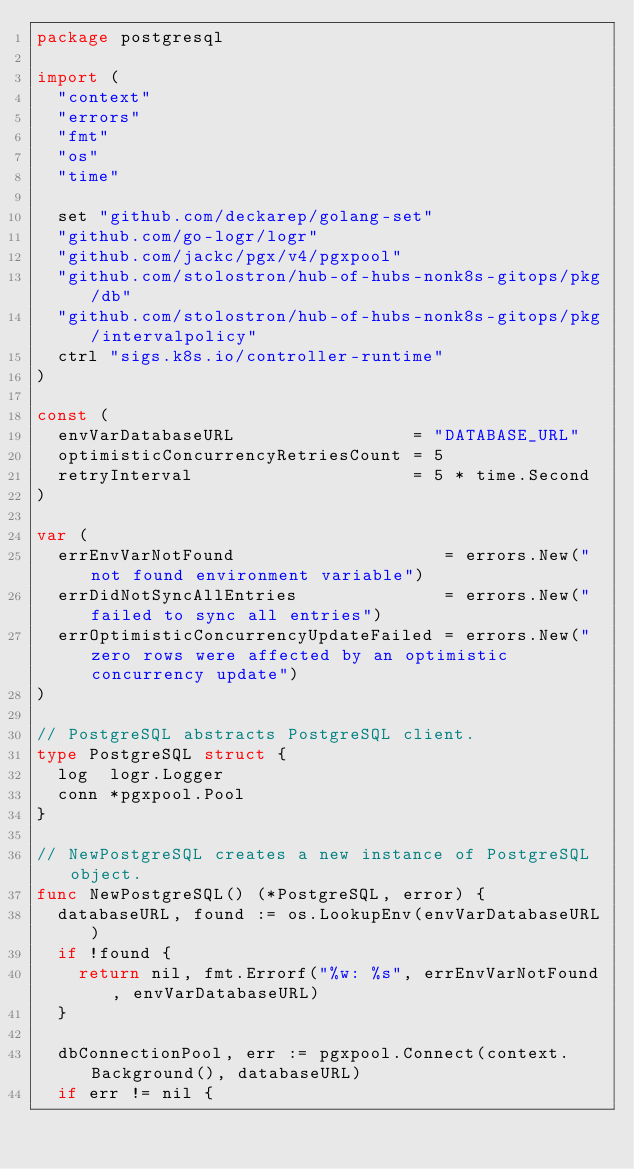<code> <loc_0><loc_0><loc_500><loc_500><_Go_>package postgresql

import (
	"context"
	"errors"
	"fmt"
	"os"
	"time"

	set "github.com/deckarep/golang-set"
	"github.com/go-logr/logr"
	"github.com/jackc/pgx/v4/pgxpool"
	"github.com/stolostron/hub-of-hubs-nonk8s-gitops/pkg/db"
	"github.com/stolostron/hub-of-hubs-nonk8s-gitops/pkg/intervalpolicy"
	ctrl "sigs.k8s.io/controller-runtime"
)

const (
	envVarDatabaseURL                 = "DATABASE_URL"
	optimisticConcurrencyRetriesCount = 5
	retryInterval                     = 5 * time.Second
)

var (
	errEnvVarNotFound                    = errors.New("not found environment variable")
	errDidNotSyncAllEntries              = errors.New("failed to sync all entries")
	errOptimisticConcurrencyUpdateFailed = errors.New("zero rows were affected by an optimistic concurrency update")
)

// PostgreSQL abstracts PostgreSQL client.
type PostgreSQL struct {
	log  logr.Logger
	conn *pgxpool.Pool
}

// NewPostgreSQL creates a new instance of PostgreSQL object.
func NewPostgreSQL() (*PostgreSQL, error) {
	databaseURL, found := os.LookupEnv(envVarDatabaseURL)
	if !found {
		return nil, fmt.Errorf("%w: %s", errEnvVarNotFound, envVarDatabaseURL)
	}

	dbConnectionPool, err := pgxpool.Connect(context.Background(), databaseURL)
	if err != nil {</code> 